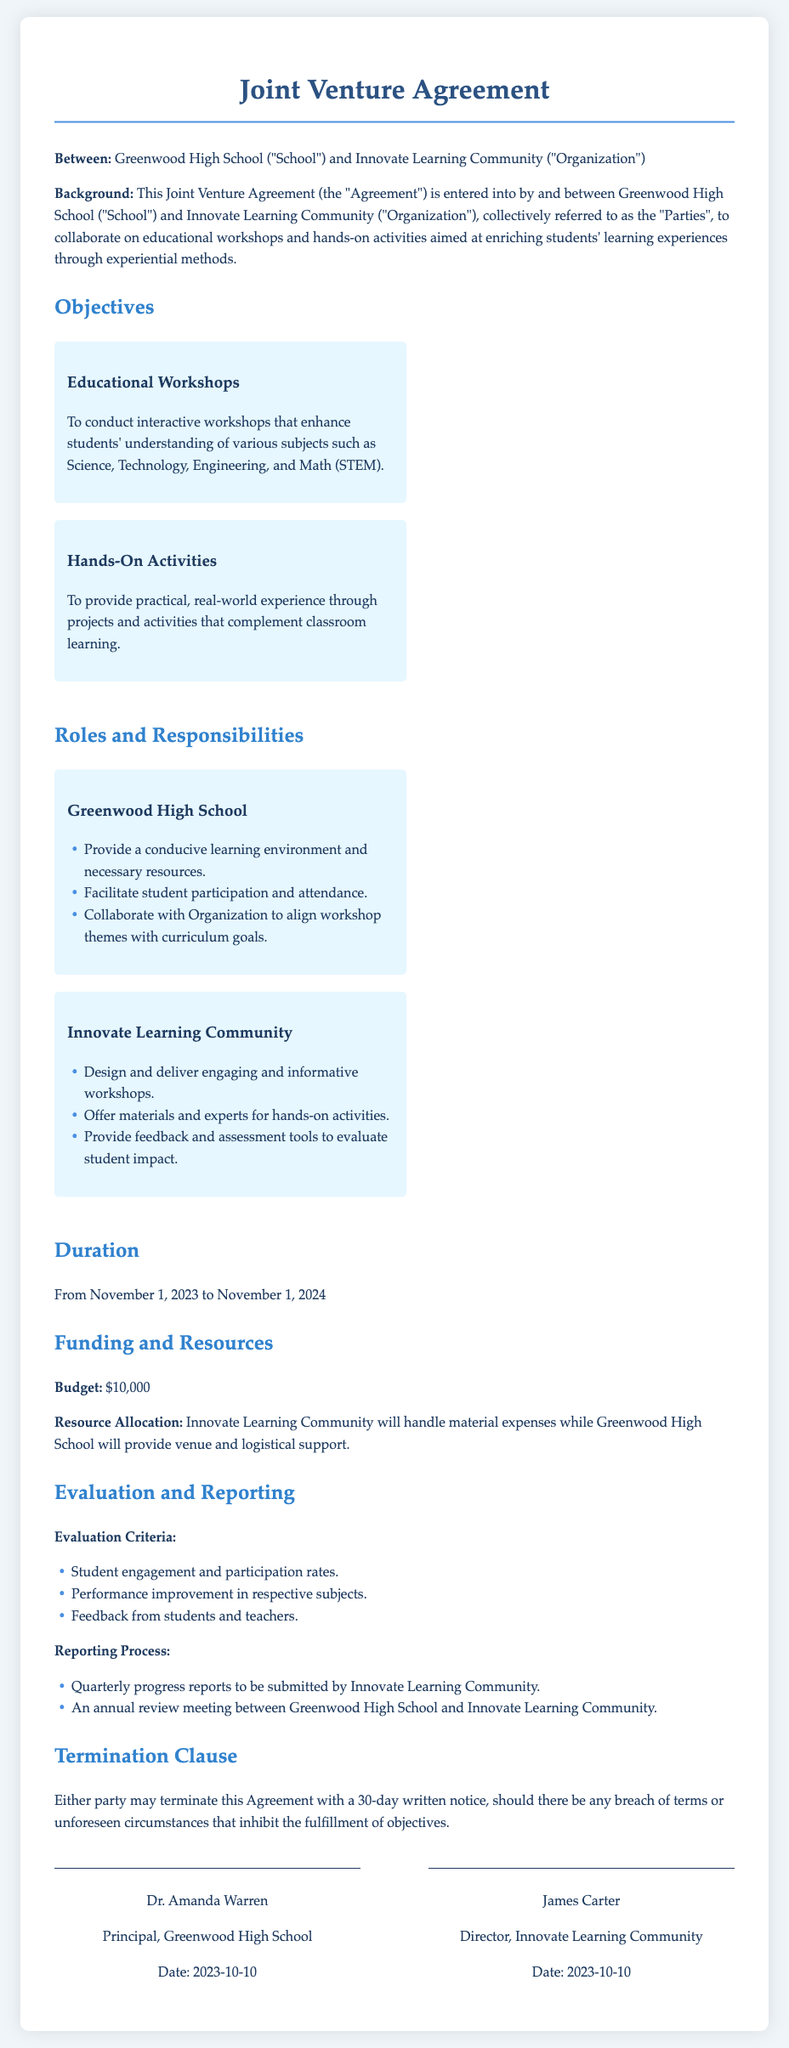What is the duration of the agreement? The duration is specified in the document with a start and end date of the agreement, which is from November 1, 2023 to November 1, 2024.
Answer: From November 1, 2023 to November 1, 2024 Who represents Greenwood High School? The document mentions the individual who has signed on behalf of Greenwood High School, which is Dr. Amanda Warren.
Answer: Dr. Amanda Warren What is the budget allocated for the joint venture? The budget is explicitly stated in the document, indicating the funds available for the collaboration.
Answer: $10,000 What is one role of Innovate Learning Community? The document lists various responsibilities for Innovate Learning Community, one of which is designing and delivering workshops.
Answer: Design and deliver engaging and informative workshops How can the Agreement be terminated? The termination clause in the document specifies the conditions under which either party can terminate the agreement.
Answer: 30-day written notice What is evaluated according to the evaluation criteria? The evaluation section outlines specific metrics to determine the success of the collaboration, including student engagement rates.
Answer: Student engagement and participation rates When are the quarterly progress reports due? The reporting process details the frequency of the reports that Innovate Learning Community must submit.
Answer: Quarterly What type of activities will be conducted? The objectives section of the document mentions the main types of activities aimed at enriching students' experiences.
Answer: Educational workshops and hands-on activities What support will Greenwood High School provide? The roles of Greenwood High School include responsibilities that include providing certain resources or environments for the workshops.
Answer: Venue and logistical support 